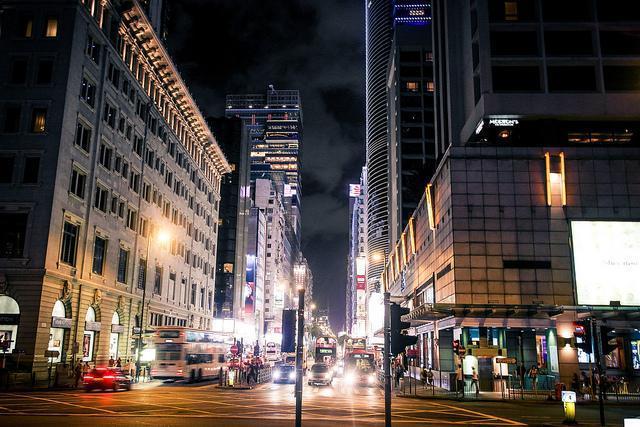How many buses can you see?
Give a very brief answer. 1. 